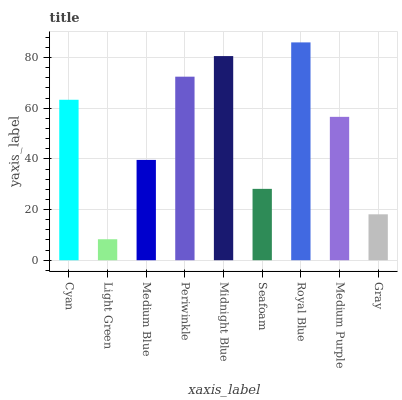Is Light Green the minimum?
Answer yes or no. Yes. Is Royal Blue the maximum?
Answer yes or no. Yes. Is Medium Blue the minimum?
Answer yes or no. No. Is Medium Blue the maximum?
Answer yes or no. No. Is Medium Blue greater than Light Green?
Answer yes or no. Yes. Is Light Green less than Medium Blue?
Answer yes or no. Yes. Is Light Green greater than Medium Blue?
Answer yes or no. No. Is Medium Blue less than Light Green?
Answer yes or no. No. Is Medium Purple the high median?
Answer yes or no. Yes. Is Medium Purple the low median?
Answer yes or no. Yes. Is Light Green the high median?
Answer yes or no. No. Is Cyan the low median?
Answer yes or no. No. 